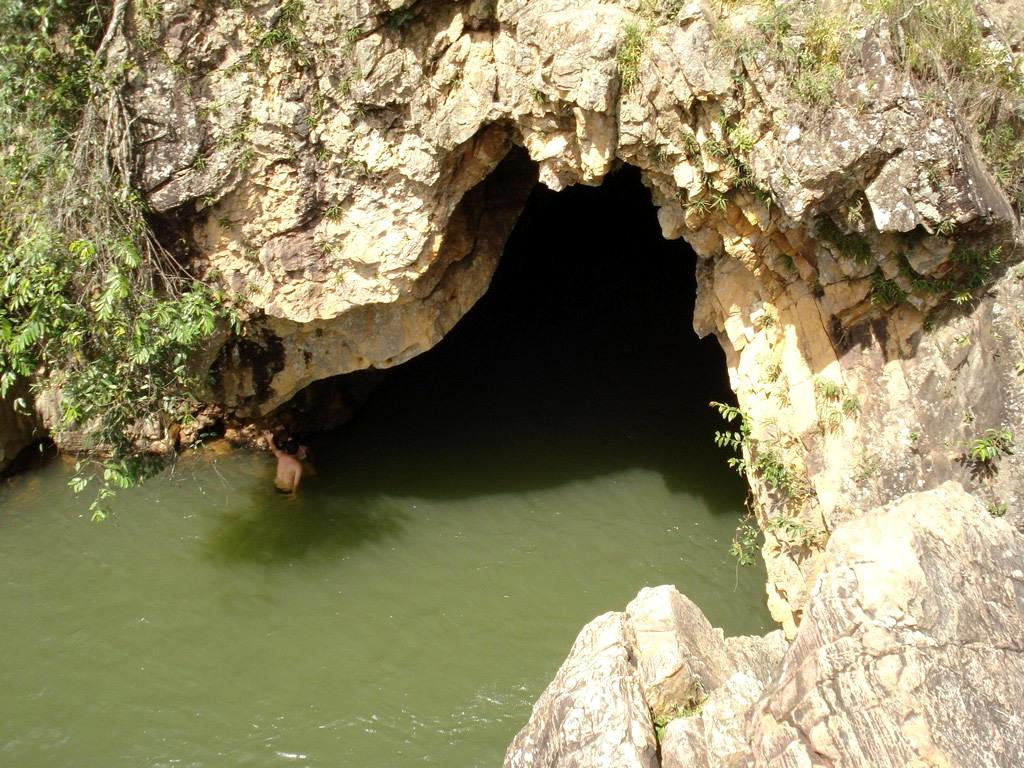What color is the water in the image? The water in the image is green. What other objects can be seen in the water? There are rocks visible in the image. Are there any living organisms in the image? Yes, there are plants in the image. What is the weight of the rabbit in the image? There is no rabbit present in the image. How many trees are visible in the image? There are no trees visible in the image. 